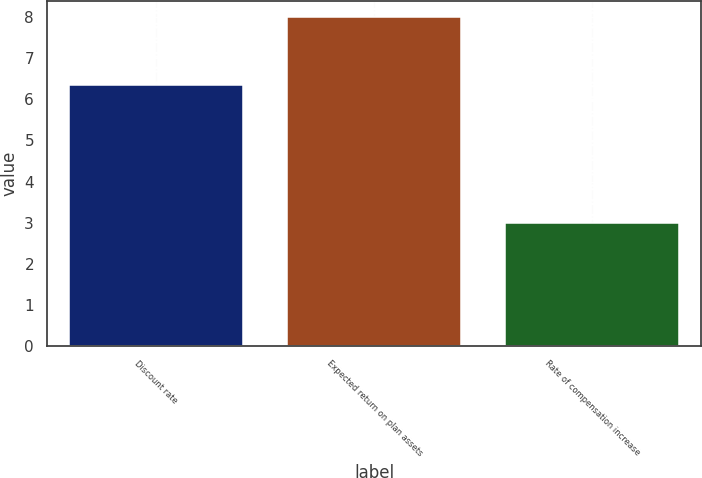<chart> <loc_0><loc_0><loc_500><loc_500><bar_chart><fcel>Discount rate<fcel>Expected return on plan assets<fcel>Rate of compensation increase<nl><fcel>6.35<fcel>8<fcel>3<nl></chart> 